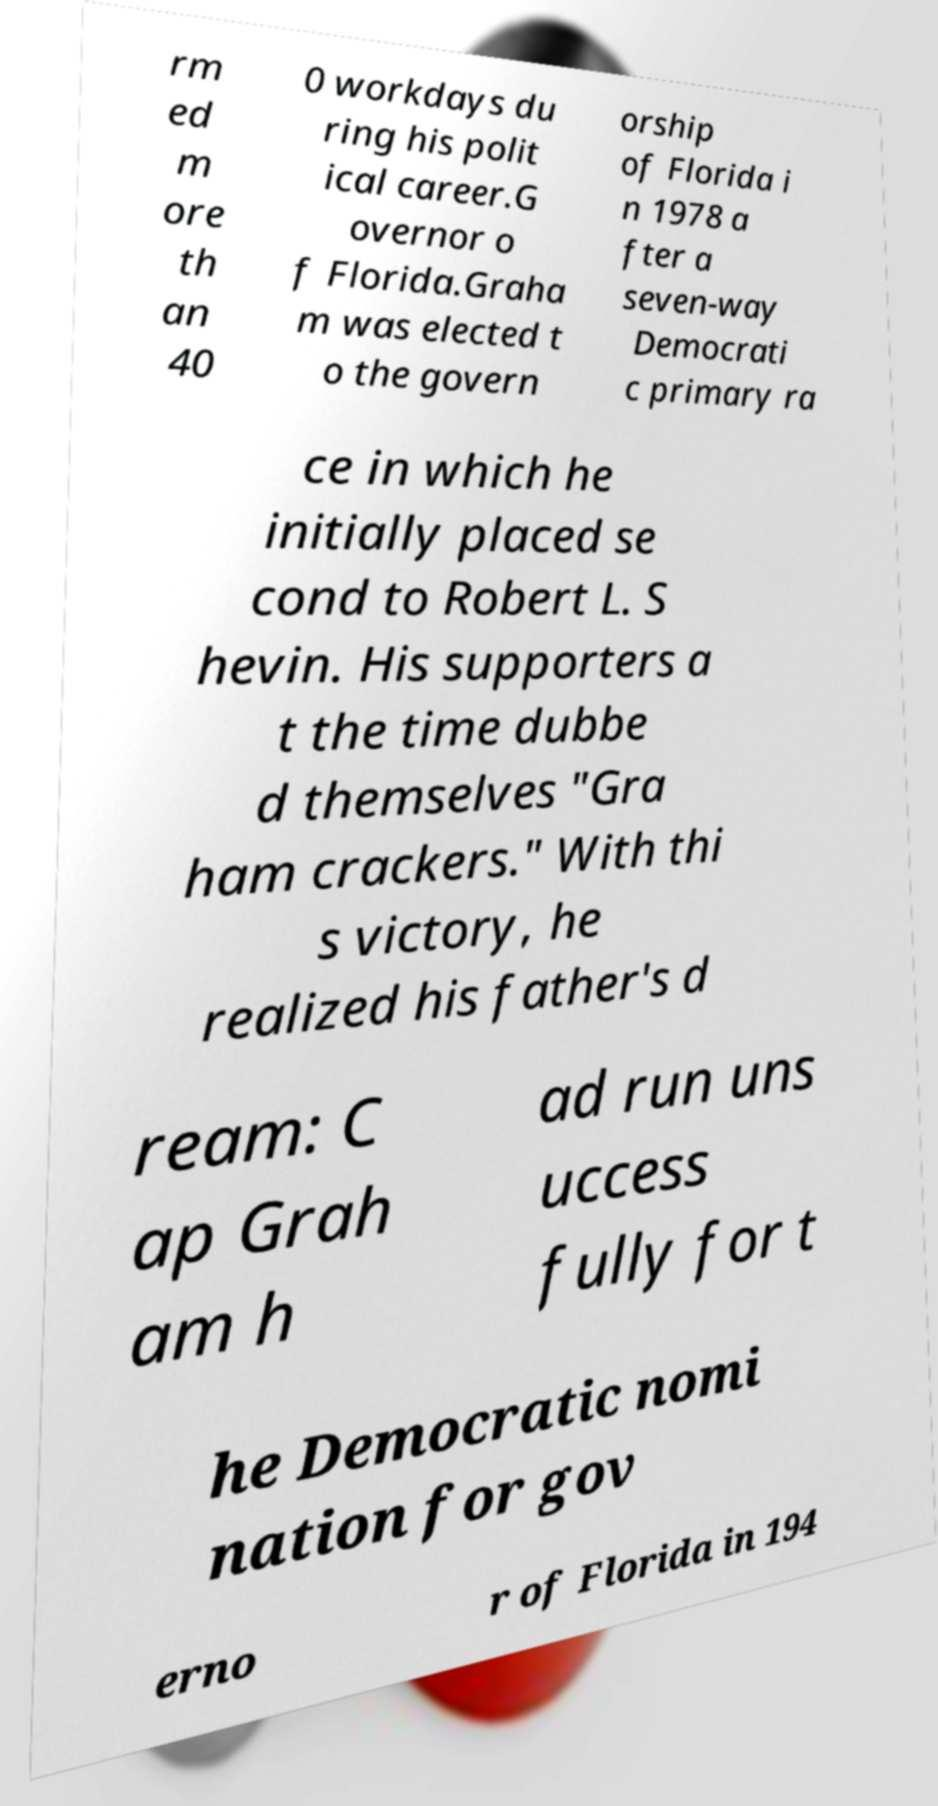Please read and relay the text visible in this image. What does it say? rm ed m ore th an 40 0 workdays du ring his polit ical career.G overnor o f Florida.Graha m was elected t o the govern orship of Florida i n 1978 a fter a seven-way Democrati c primary ra ce in which he initially placed se cond to Robert L. S hevin. His supporters a t the time dubbe d themselves "Gra ham crackers." With thi s victory, he realized his father's d ream: C ap Grah am h ad run uns uccess fully for t he Democratic nomi nation for gov erno r of Florida in 194 